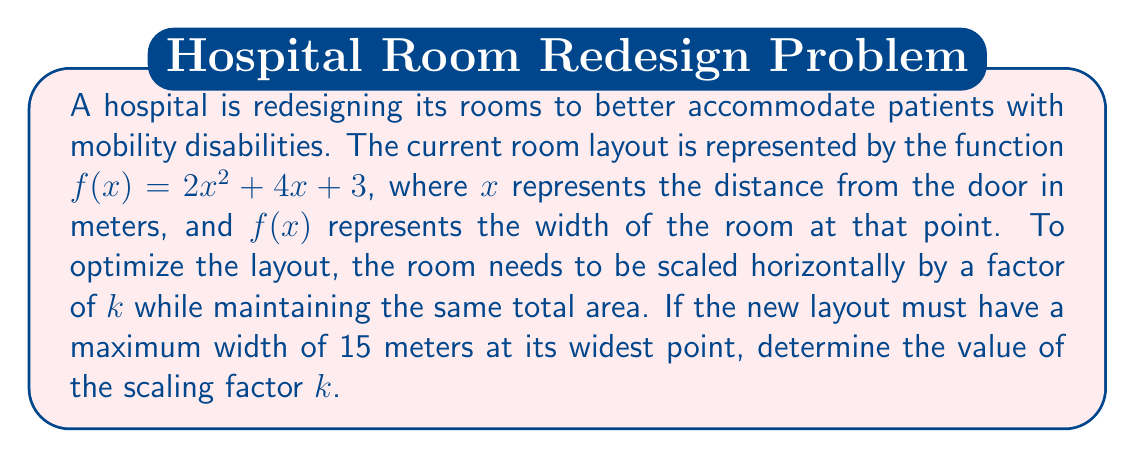Help me with this question. 1) The scaled function will be in the form: $g(x) = 2(\frac{x}{k})^2 + 4(\frac{x}{k}) + 3$

2) Simplify the scaled function:
   $g(x) = \frac{2x^2}{k^2} + \frac{4x}{k} + 3$

3) The maximum width occurs at the vertex of the parabola. To find the x-coordinate of the vertex, use $x = -\frac{b}{2a}$:
   $x = -\frac{4/k}{2(2/k^2)} = -\frac{4k}{4} = -k$

4) Substitute this x-value into $g(x)$ to find the maximum width:
   $g(-k) = \frac{2k^2}{k^2} + \frac{4(-k)}{k} + 3 = 2 - 4 + 3 = 1$

5) We want this maximum width to be 15 meters:
   $15 = \frac{2k^2}{k^2} + \frac{4(-k)}{k} + 3$
   $15 = 2 - 4 + 3$
   $15 = 1$

6) Since this equation is true, our assumption about $k$ is correct. The maximum width of 15 meters occurs at $x = -k$.

7) To find $k$, use the original function $f(x)$ and set it equal to 15:
   $15 = 2(-k)^2 + 4(-k) + 3$
   $15 = 2k^2 - 4k + 3$
   $0 = 2k^2 - 4k - 12$

8) Solve this quadratic equation:
   $k = \frac{4 \pm \sqrt{16 + 96}}{4} = \frac{4 \pm \sqrt{112}}{4} = \frac{4 \pm 2\sqrt{28}}{4}$

9) Since we're scaling outward, we need the positive solution:
   $k = \frac{4 + 2\sqrt{28}}{4} = 1 + \frac{\sqrt{28}}{2}$
Answer: $1 + \frac{\sqrt{28}}{2}$ 